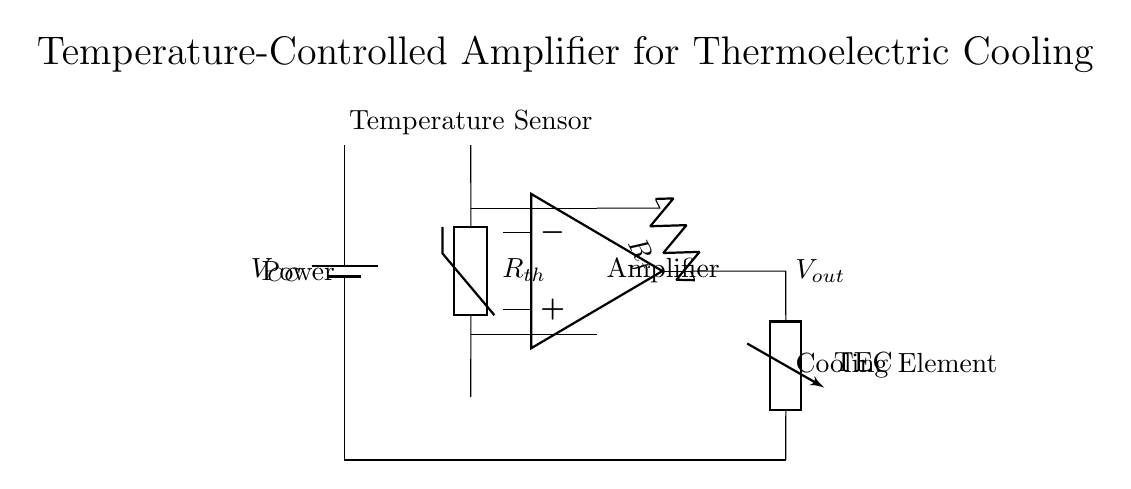What type of sensor is used in this circuit? The circuit includes a thermistor, which is a type of temperature sensor that changes resistance based on temperature.
Answer: Thermistor What does the output of the amplifier control? The output of the amplifier is connected to a thermoelectric cooler, which it regulates based on the temperature sensor's input.
Answer: Thermoelectric cooler What is the role of resistor R_f in the circuit? Resistor R_f provides feedback to the operational amplifier, influencing its gain and stability in responding to temperature changes from the thermistor.
Answer: Feedback How many main components are present in the circuit? The circuit consists of four major components: a power supply, a thermistor, an operational amplifier, and a thermoelectric cooler.
Answer: Four What does V_out represent in the circuit? V_out is the output voltage from the operational amplifier, which reflects the amplified temperature signal and controls the cooling element.
Answer: Output voltage How does the thermistor affect the operation of the amplifier? The thermistor detects ambient temperature changes and alters its resistance, which affects the input voltage to the operational amplifier, allowing it to adjust the cooling output accordingly.
Answer: Temperature adaptation 